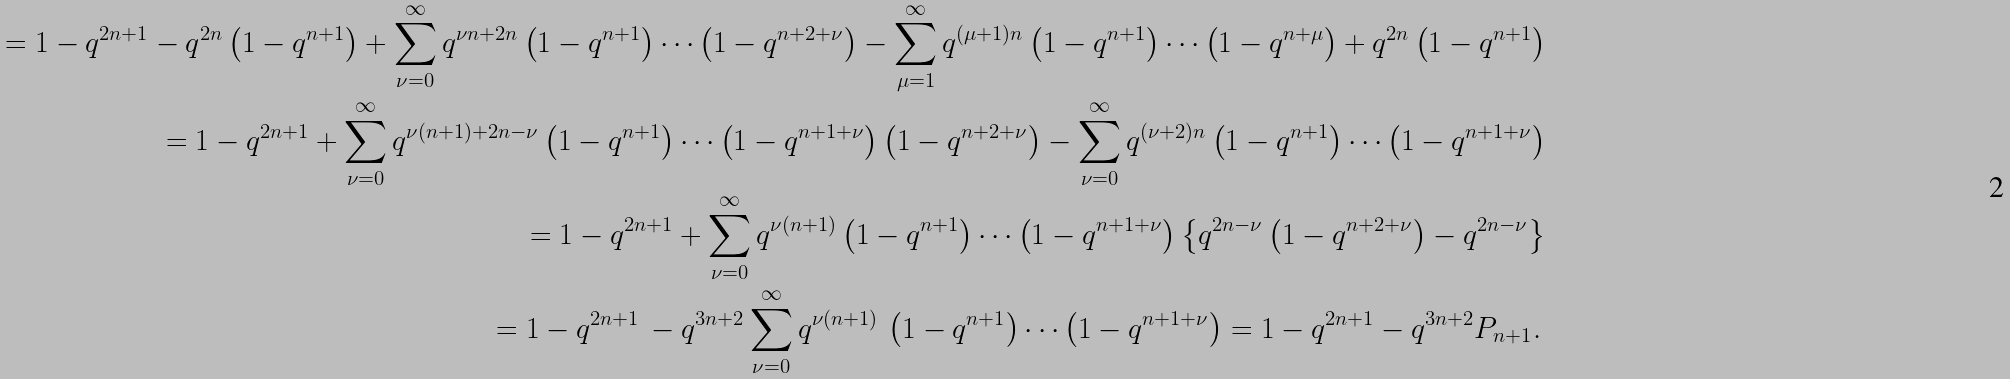Convert formula to latex. <formula><loc_0><loc_0><loc_500><loc_500>= 1 - q ^ { 2 n + 1 } - q ^ { 2 n } \left ( 1 - q ^ { n + 1 } \right ) + \sum ^ { \infty } _ { \nu = 0 } q ^ { \nu n + 2 n } \left ( 1 - q ^ { n + 1 } \right ) \cdots \left ( 1 - q ^ { n + 2 + \nu } \right ) - \sum ^ { \infty } _ { \mu = 1 } q ^ { ( \mu + 1 ) n } \left ( 1 - q ^ { n + 1 } \right ) \cdots \left ( 1 - q ^ { n + \mu } \right ) + q ^ { 2 n } \left ( 1 - q ^ { n + 1 } \right ) \\ = 1 - q ^ { 2 n + 1 } + \sum ^ { \infty } _ { \nu = 0 } q ^ { \nu ( n + 1 ) + 2 n - \nu } \left ( 1 - q ^ { n + 1 } \right ) \cdots \left ( 1 - q ^ { n + 1 + \nu } \right ) \left ( 1 - q ^ { n + 2 + \nu } \right ) - \sum ^ { \infty } _ { \nu = 0 } q ^ { ( \nu + 2 ) n } \left ( 1 - q ^ { n + 1 } \right ) \cdots \left ( 1 - q ^ { n + 1 + \nu } \right ) \\ = 1 - q ^ { 2 n + 1 } + \sum ^ { \infty } _ { \nu = 0 } q ^ { \nu ( n + 1 ) } \left ( 1 - q ^ { n + 1 } \right ) \cdots \left ( 1 - q ^ { n + 1 + \nu } \right ) \left \{ q ^ { 2 n - \nu } \left ( 1 - q ^ { n + 2 + \nu } \right ) - q ^ { 2 n - \nu } \right \} \\ = 1 - q ^ { 2 n + 1 } \, - q ^ { 3 n + 2 } \sum ^ { \infty } _ { \nu = 0 } q ^ { \nu ( n + 1 ) } \, \left ( 1 - q ^ { n + 1 } \right ) \cdots \left ( 1 - q ^ { n + 1 + \nu } \right ) = 1 - q ^ { 2 n + 1 } - q ^ { 3 n + 2 } P _ { n + 1 } . \,</formula> 